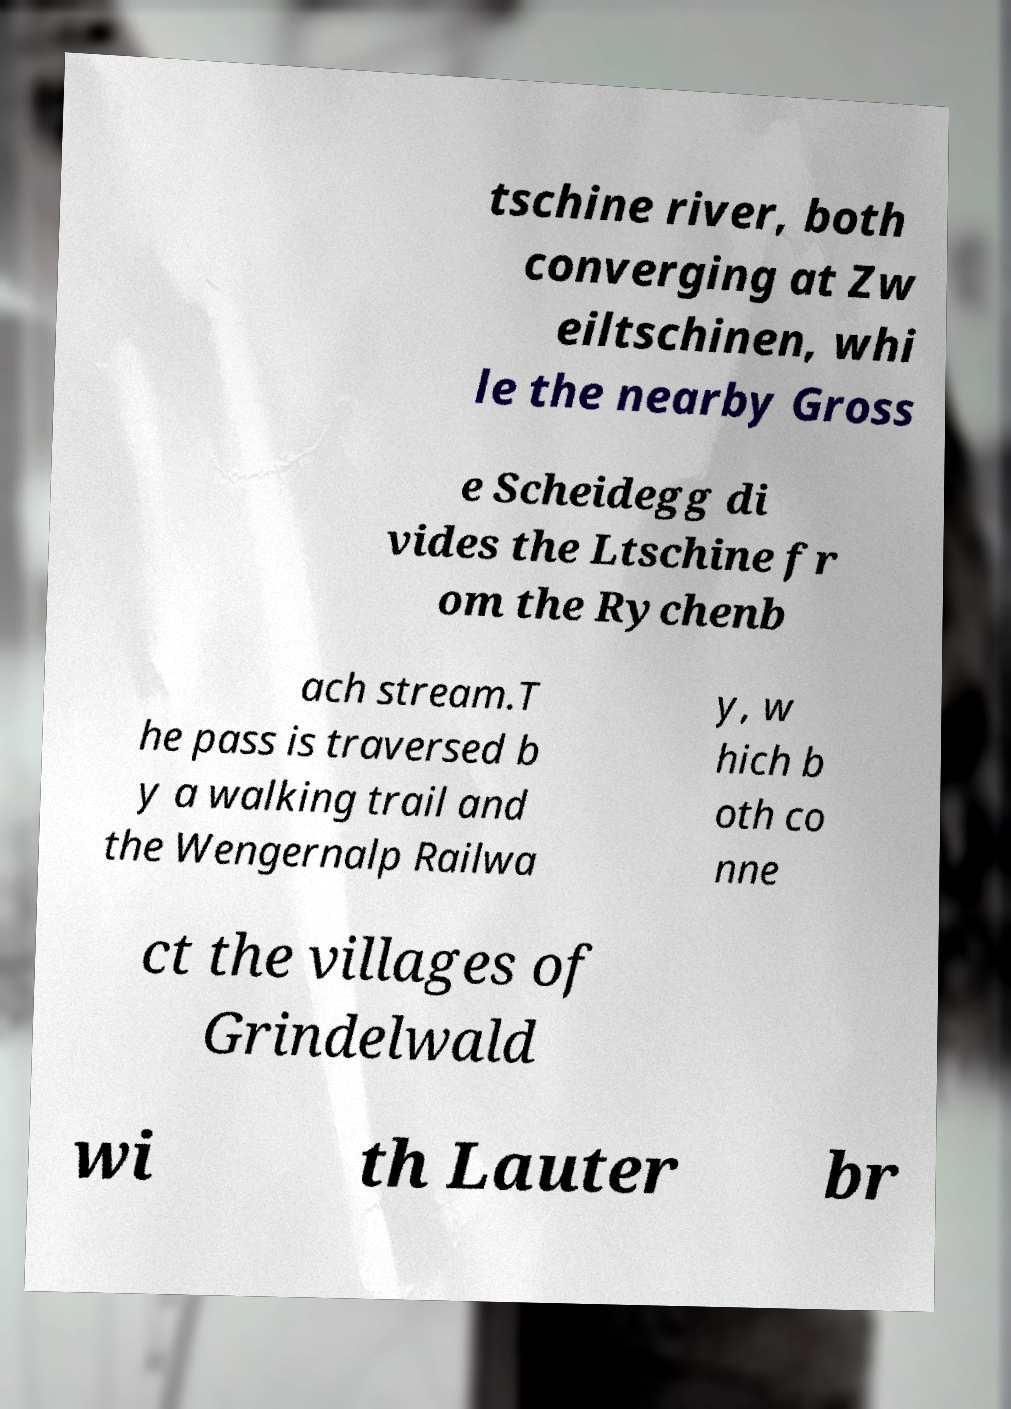Could you assist in decoding the text presented in this image and type it out clearly? tschine river, both converging at Zw eiltschinen, whi le the nearby Gross e Scheidegg di vides the Ltschine fr om the Rychenb ach stream.T he pass is traversed b y a walking trail and the Wengernalp Railwa y, w hich b oth co nne ct the villages of Grindelwald wi th Lauter br 